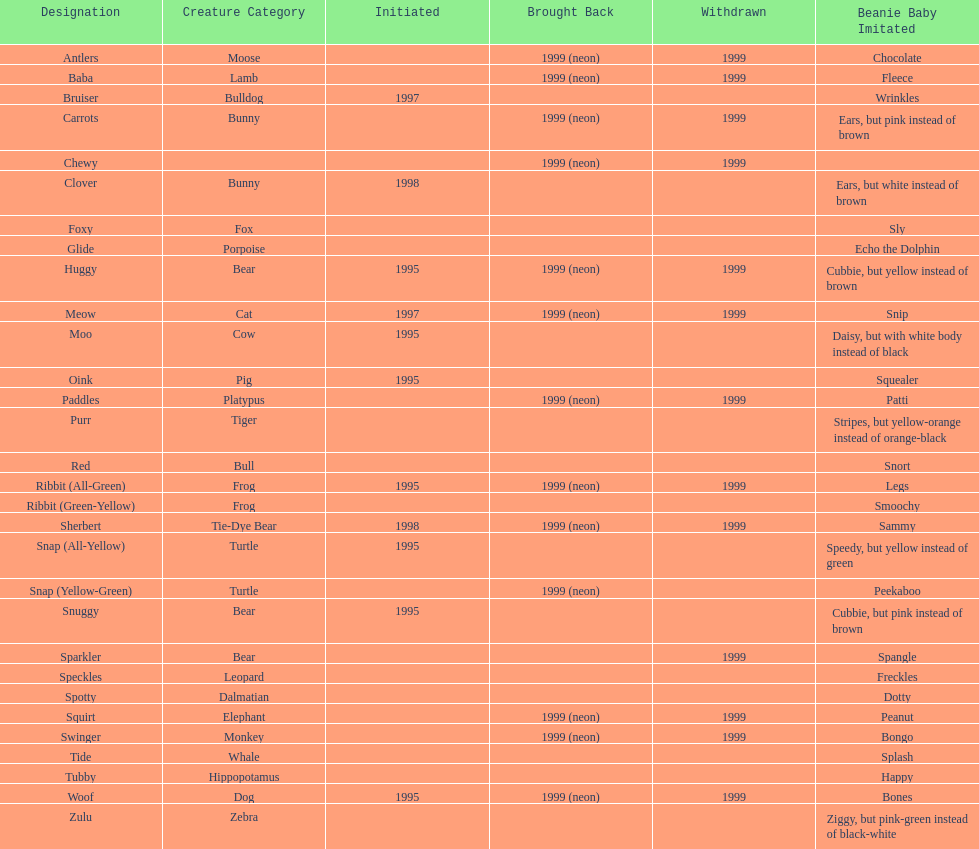How many total pillow pals were both reintroduced and retired in 1999? 12. 